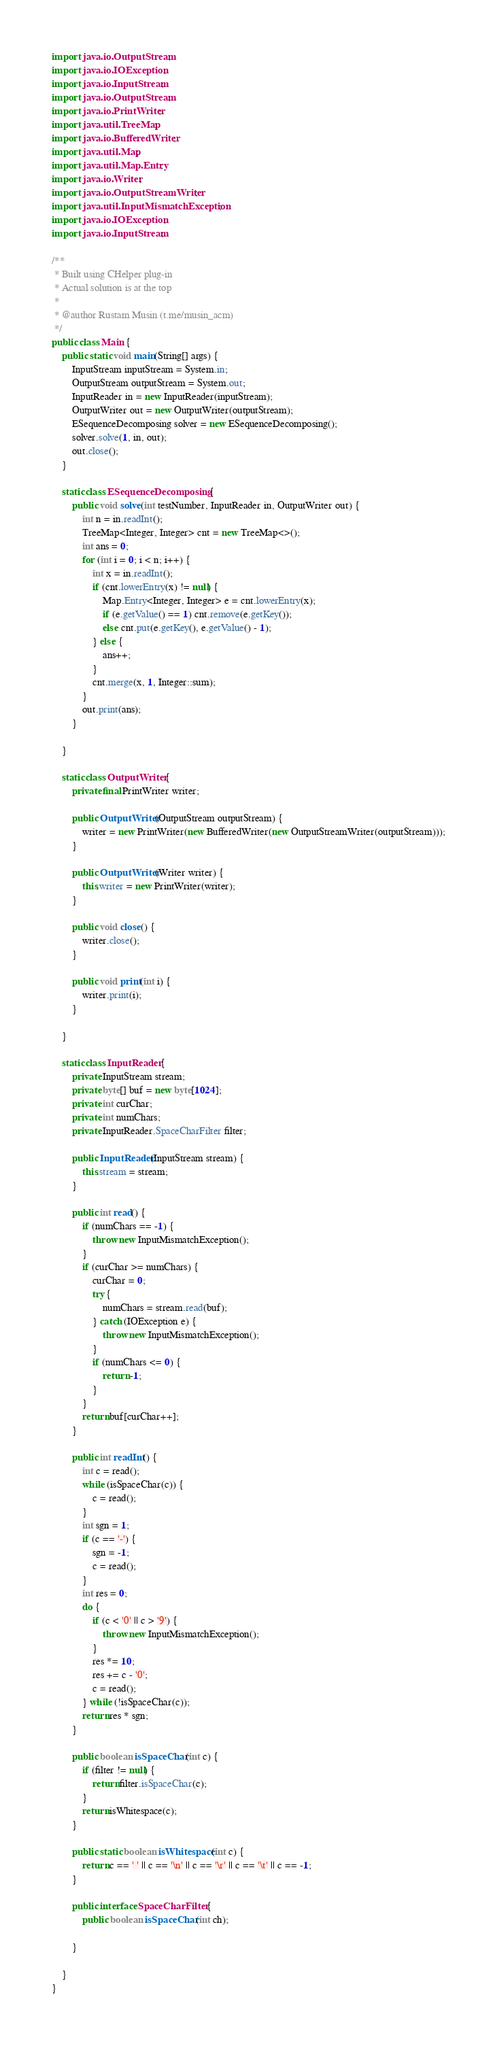<code> <loc_0><loc_0><loc_500><loc_500><_Java_>import java.io.OutputStream;
import java.io.IOException;
import java.io.InputStream;
import java.io.OutputStream;
import java.io.PrintWriter;
import java.util.TreeMap;
import java.io.BufferedWriter;
import java.util.Map;
import java.util.Map.Entry;
import java.io.Writer;
import java.io.OutputStreamWriter;
import java.util.InputMismatchException;
import java.io.IOException;
import java.io.InputStream;

/**
 * Built using CHelper plug-in
 * Actual solution is at the top
 *
 * @author Rustam Musin (t.me/musin_acm)
 */
public class Main {
    public static void main(String[] args) {
        InputStream inputStream = System.in;
        OutputStream outputStream = System.out;
        InputReader in = new InputReader(inputStream);
        OutputWriter out = new OutputWriter(outputStream);
        ESequenceDecomposing solver = new ESequenceDecomposing();
        solver.solve(1, in, out);
        out.close();
    }

    static class ESequenceDecomposing {
        public void solve(int testNumber, InputReader in, OutputWriter out) {
            int n = in.readInt();
            TreeMap<Integer, Integer> cnt = new TreeMap<>();
            int ans = 0;
            for (int i = 0; i < n; i++) {
                int x = in.readInt();
                if (cnt.lowerEntry(x) != null) {
                    Map.Entry<Integer, Integer> e = cnt.lowerEntry(x);
                    if (e.getValue() == 1) cnt.remove(e.getKey());
                    else cnt.put(e.getKey(), e.getValue() - 1);
                } else {
                    ans++;
                }
                cnt.merge(x, 1, Integer::sum);
            }
            out.print(ans);
        }

    }

    static class OutputWriter {
        private final PrintWriter writer;

        public OutputWriter(OutputStream outputStream) {
            writer = new PrintWriter(new BufferedWriter(new OutputStreamWriter(outputStream)));
        }

        public OutputWriter(Writer writer) {
            this.writer = new PrintWriter(writer);
        }

        public void close() {
            writer.close();
        }

        public void print(int i) {
            writer.print(i);
        }

    }

    static class InputReader {
        private InputStream stream;
        private byte[] buf = new byte[1024];
        private int curChar;
        private int numChars;
        private InputReader.SpaceCharFilter filter;

        public InputReader(InputStream stream) {
            this.stream = stream;
        }

        public int read() {
            if (numChars == -1) {
                throw new InputMismatchException();
            }
            if (curChar >= numChars) {
                curChar = 0;
                try {
                    numChars = stream.read(buf);
                } catch (IOException e) {
                    throw new InputMismatchException();
                }
                if (numChars <= 0) {
                    return -1;
                }
            }
            return buf[curChar++];
        }

        public int readInt() {
            int c = read();
            while (isSpaceChar(c)) {
                c = read();
            }
            int sgn = 1;
            if (c == '-') {
                sgn = -1;
                c = read();
            }
            int res = 0;
            do {
                if (c < '0' || c > '9') {
                    throw new InputMismatchException();
                }
                res *= 10;
                res += c - '0';
                c = read();
            } while (!isSpaceChar(c));
            return res * sgn;
        }

        public boolean isSpaceChar(int c) {
            if (filter != null) {
                return filter.isSpaceChar(c);
            }
            return isWhitespace(c);
        }

        public static boolean isWhitespace(int c) {
            return c == ' ' || c == '\n' || c == '\r' || c == '\t' || c == -1;
        }

        public interface SpaceCharFilter {
            public boolean isSpaceChar(int ch);

        }

    }
}

</code> 